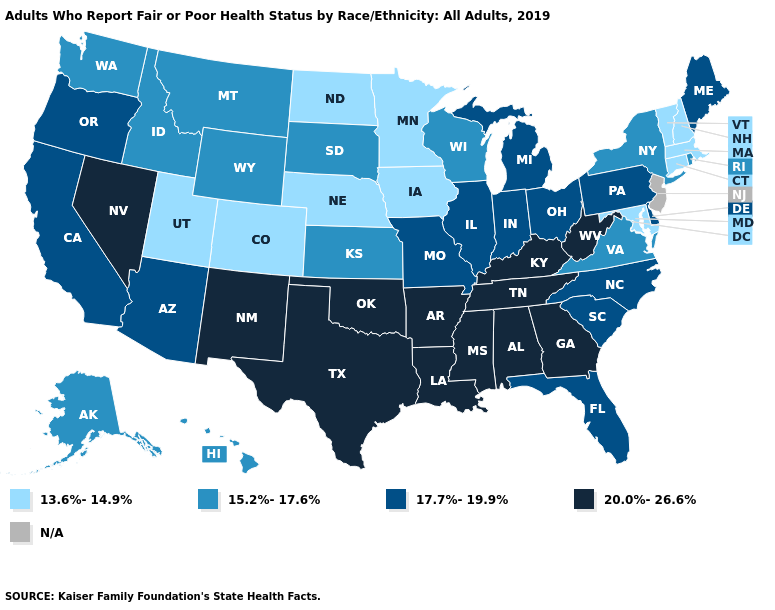Name the states that have a value in the range 17.7%-19.9%?
Concise answer only. Arizona, California, Delaware, Florida, Illinois, Indiana, Maine, Michigan, Missouri, North Carolina, Ohio, Oregon, Pennsylvania, South Carolina. What is the value of Arkansas?
Be succinct. 20.0%-26.6%. What is the lowest value in states that border Montana?
Be succinct. 13.6%-14.9%. Name the states that have a value in the range 13.6%-14.9%?
Quick response, please. Colorado, Connecticut, Iowa, Maryland, Massachusetts, Minnesota, Nebraska, New Hampshire, North Dakota, Utah, Vermont. Does Colorado have the lowest value in the West?
Answer briefly. Yes. Among the states that border Idaho , does Nevada have the highest value?
Write a very short answer. Yes. What is the value of Rhode Island?
Quick response, please. 15.2%-17.6%. Does Louisiana have the lowest value in the South?
Concise answer only. No. Name the states that have a value in the range 17.7%-19.9%?
Give a very brief answer. Arizona, California, Delaware, Florida, Illinois, Indiana, Maine, Michigan, Missouri, North Carolina, Ohio, Oregon, Pennsylvania, South Carolina. What is the value of California?
Answer briefly. 17.7%-19.9%. What is the value of Iowa?
Be succinct. 13.6%-14.9%. What is the value of Virginia?
Short answer required. 15.2%-17.6%. Name the states that have a value in the range 17.7%-19.9%?
Answer briefly. Arizona, California, Delaware, Florida, Illinois, Indiana, Maine, Michigan, Missouri, North Carolina, Ohio, Oregon, Pennsylvania, South Carolina. 